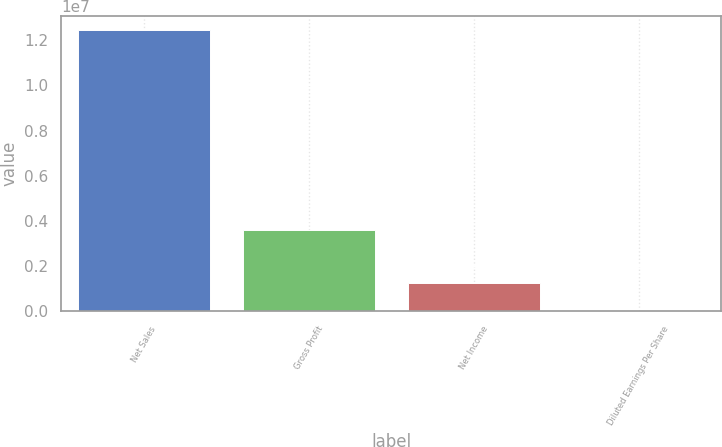Convert chart to OTSL. <chart><loc_0><loc_0><loc_500><loc_500><bar_chart><fcel>Net Sales<fcel>Gross Profit<fcel>Net Income<fcel>Diluted Earnings Per Share<nl><fcel>1.24589e+07<fcel>3.60604e+06<fcel>1.24589e+06<fcel>3.58<nl></chart> 